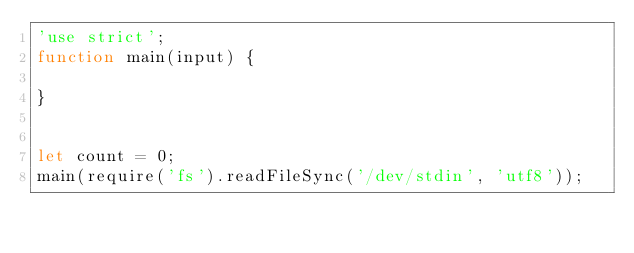Convert code to text. <code><loc_0><loc_0><loc_500><loc_500><_JavaScript_>'use strict';
function main(input) {
 
}


let count = 0;
main(require('fs').readFileSync('/dev/stdin', 'utf8'));</code> 